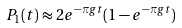Convert formula to latex. <formula><loc_0><loc_0><loc_500><loc_500>P _ { 1 } ( t ) \approx 2 e ^ { - \pi g t } ( 1 - e ^ { - \pi g t } )</formula> 